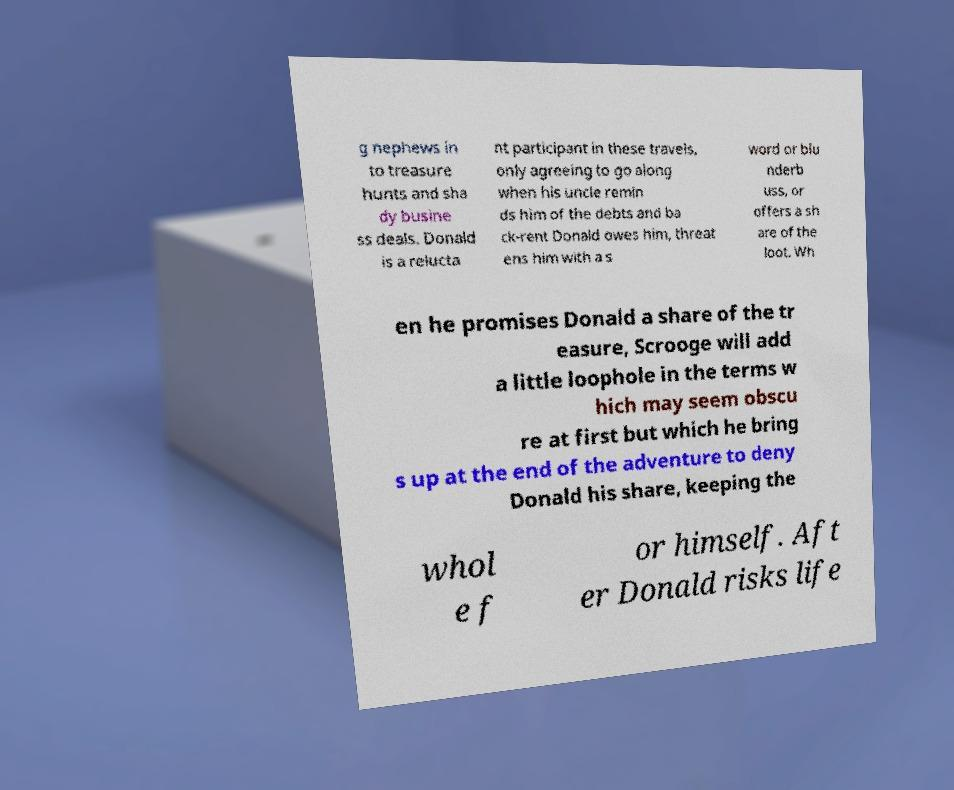Please identify and transcribe the text found in this image. g nephews in to treasure hunts and sha dy busine ss deals. Donald is a relucta nt participant in these travels, only agreeing to go along when his uncle remin ds him of the debts and ba ck-rent Donald owes him, threat ens him with a s word or blu nderb uss, or offers a sh are of the loot. Wh en he promises Donald a share of the tr easure, Scrooge will add a little loophole in the terms w hich may seem obscu re at first but which he bring s up at the end of the adventure to deny Donald his share, keeping the whol e f or himself. Aft er Donald risks life 